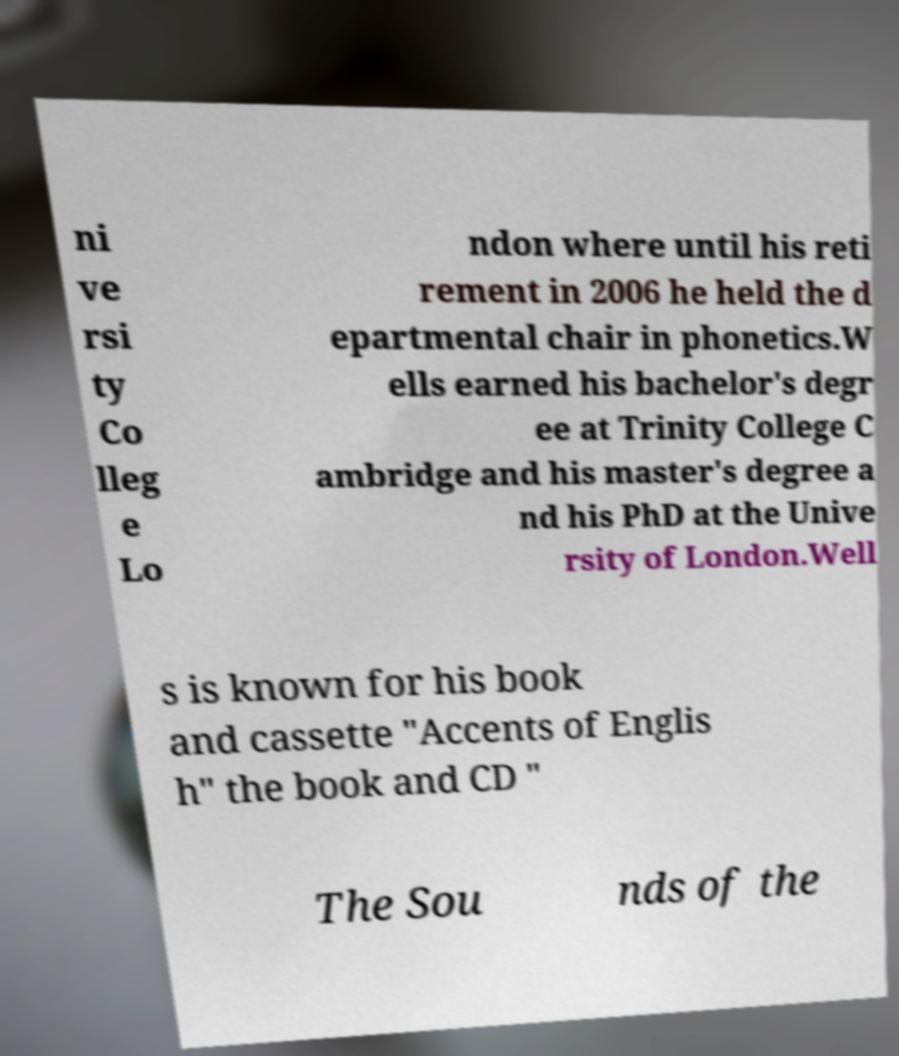There's text embedded in this image that I need extracted. Can you transcribe it verbatim? ni ve rsi ty Co lleg e Lo ndon where until his reti rement in 2006 he held the d epartmental chair in phonetics.W ells earned his bachelor's degr ee at Trinity College C ambridge and his master's degree a nd his PhD at the Unive rsity of London.Well s is known for his book and cassette "Accents of Englis h" the book and CD " The Sou nds of the 